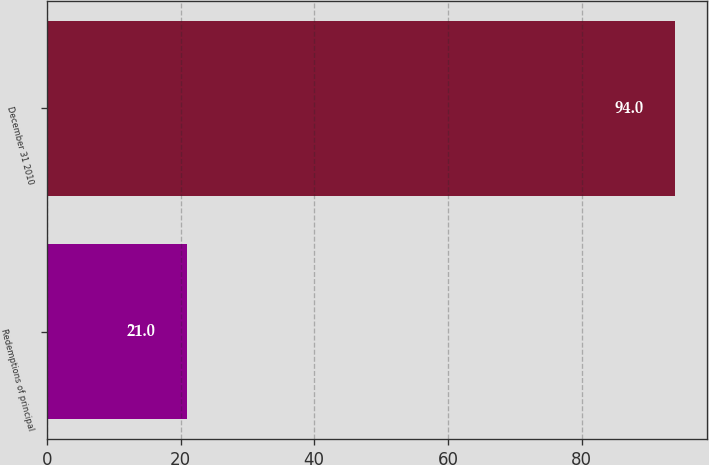Convert chart. <chart><loc_0><loc_0><loc_500><loc_500><bar_chart><fcel>Redemptions of principal<fcel>December 31 2010<nl><fcel>21<fcel>94<nl></chart> 